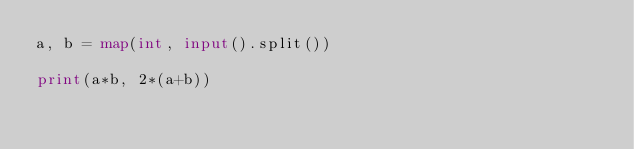<code> <loc_0><loc_0><loc_500><loc_500><_Python_>a, b = map(int, input().split())

print(a*b, 2*(a+b))
</code> 